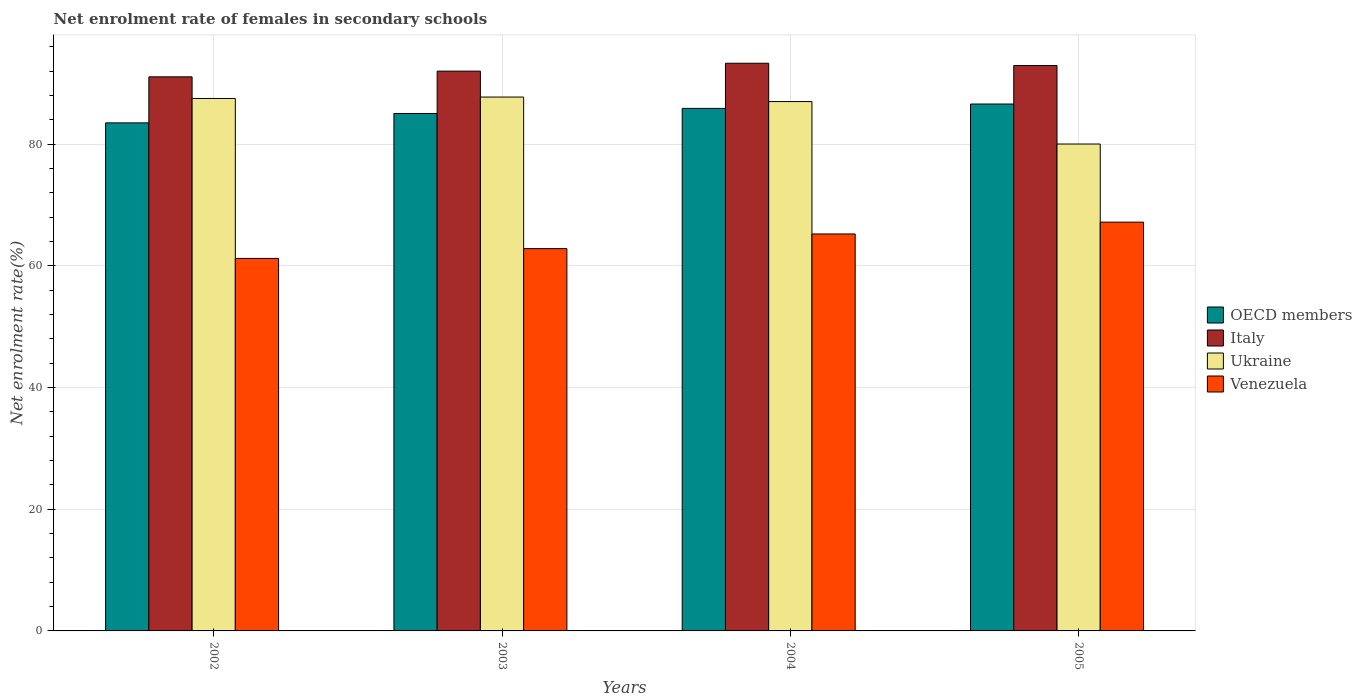How many different coloured bars are there?
Make the answer very short. 4. Are the number of bars on each tick of the X-axis equal?
Your answer should be compact. Yes. How many bars are there on the 4th tick from the left?
Make the answer very short. 4. What is the net enrolment rate of females in secondary schools in OECD members in 2002?
Offer a terse response. 83.5. Across all years, what is the maximum net enrolment rate of females in secondary schools in Ukraine?
Make the answer very short. 87.75. Across all years, what is the minimum net enrolment rate of females in secondary schools in Ukraine?
Make the answer very short. 80.02. In which year was the net enrolment rate of females in secondary schools in Venezuela minimum?
Your response must be concise. 2002. What is the total net enrolment rate of females in secondary schools in Italy in the graph?
Provide a short and direct response. 369.31. What is the difference between the net enrolment rate of females in secondary schools in Italy in 2002 and that in 2003?
Offer a very short reply. -0.94. What is the difference between the net enrolment rate of females in secondary schools in Ukraine in 2005 and the net enrolment rate of females in secondary schools in Italy in 2004?
Provide a succinct answer. -13.28. What is the average net enrolment rate of females in secondary schools in Ukraine per year?
Offer a very short reply. 85.57. In the year 2004, what is the difference between the net enrolment rate of females in secondary schools in Venezuela and net enrolment rate of females in secondary schools in OECD members?
Provide a short and direct response. -20.64. In how many years, is the net enrolment rate of females in secondary schools in OECD members greater than 8 %?
Your answer should be compact. 4. What is the ratio of the net enrolment rate of females in secondary schools in Venezuela in 2004 to that in 2005?
Your answer should be compact. 0.97. Is the difference between the net enrolment rate of females in secondary schools in Venezuela in 2002 and 2005 greater than the difference between the net enrolment rate of females in secondary schools in OECD members in 2002 and 2005?
Provide a succinct answer. No. What is the difference between the highest and the second highest net enrolment rate of females in secondary schools in Venezuela?
Provide a succinct answer. 1.94. What is the difference between the highest and the lowest net enrolment rate of females in secondary schools in Ukraine?
Keep it short and to the point. 7.72. In how many years, is the net enrolment rate of females in secondary schools in Venezuela greater than the average net enrolment rate of females in secondary schools in Venezuela taken over all years?
Your answer should be very brief. 2. What does the 2nd bar from the left in 2003 represents?
Your answer should be very brief. Italy. What does the 4th bar from the right in 2004 represents?
Your answer should be very brief. OECD members. How many bars are there?
Make the answer very short. 16. Are all the bars in the graph horizontal?
Provide a short and direct response. No. How many years are there in the graph?
Make the answer very short. 4. What is the difference between two consecutive major ticks on the Y-axis?
Your answer should be compact. 20. Are the values on the major ticks of Y-axis written in scientific E-notation?
Make the answer very short. No. Does the graph contain any zero values?
Make the answer very short. No. Where does the legend appear in the graph?
Your answer should be very brief. Center right. What is the title of the graph?
Make the answer very short. Net enrolment rate of females in secondary schools. What is the label or title of the Y-axis?
Your response must be concise. Net enrolment rate(%). What is the Net enrolment rate(%) in OECD members in 2002?
Give a very brief answer. 83.5. What is the Net enrolment rate(%) in Italy in 2002?
Provide a short and direct response. 91.07. What is the Net enrolment rate(%) in Ukraine in 2002?
Offer a very short reply. 87.51. What is the Net enrolment rate(%) of Venezuela in 2002?
Offer a very short reply. 61.22. What is the Net enrolment rate(%) in OECD members in 2003?
Ensure brevity in your answer.  85.05. What is the Net enrolment rate(%) of Italy in 2003?
Your response must be concise. 92.01. What is the Net enrolment rate(%) of Ukraine in 2003?
Your answer should be compact. 87.75. What is the Net enrolment rate(%) of Venezuela in 2003?
Ensure brevity in your answer.  62.83. What is the Net enrolment rate(%) in OECD members in 2004?
Provide a succinct answer. 85.88. What is the Net enrolment rate(%) in Italy in 2004?
Provide a short and direct response. 93.3. What is the Net enrolment rate(%) of Ukraine in 2004?
Keep it short and to the point. 87. What is the Net enrolment rate(%) of Venezuela in 2004?
Give a very brief answer. 65.24. What is the Net enrolment rate(%) of OECD members in 2005?
Make the answer very short. 86.6. What is the Net enrolment rate(%) in Italy in 2005?
Give a very brief answer. 92.93. What is the Net enrolment rate(%) of Ukraine in 2005?
Make the answer very short. 80.02. What is the Net enrolment rate(%) in Venezuela in 2005?
Offer a very short reply. 67.18. Across all years, what is the maximum Net enrolment rate(%) of OECD members?
Give a very brief answer. 86.6. Across all years, what is the maximum Net enrolment rate(%) in Italy?
Your response must be concise. 93.3. Across all years, what is the maximum Net enrolment rate(%) in Ukraine?
Offer a very short reply. 87.75. Across all years, what is the maximum Net enrolment rate(%) in Venezuela?
Provide a short and direct response. 67.18. Across all years, what is the minimum Net enrolment rate(%) in OECD members?
Give a very brief answer. 83.5. Across all years, what is the minimum Net enrolment rate(%) in Italy?
Provide a succinct answer. 91.07. Across all years, what is the minimum Net enrolment rate(%) in Ukraine?
Provide a succinct answer. 80.02. Across all years, what is the minimum Net enrolment rate(%) of Venezuela?
Ensure brevity in your answer.  61.22. What is the total Net enrolment rate(%) of OECD members in the graph?
Your answer should be compact. 341.03. What is the total Net enrolment rate(%) of Italy in the graph?
Your answer should be very brief. 369.31. What is the total Net enrolment rate(%) of Ukraine in the graph?
Offer a very short reply. 342.28. What is the total Net enrolment rate(%) in Venezuela in the graph?
Make the answer very short. 256.48. What is the difference between the Net enrolment rate(%) in OECD members in 2002 and that in 2003?
Your answer should be very brief. -1.54. What is the difference between the Net enrolment rate(%) of Italy in 2002 and that in 2003?
Provide a short and direct response. -0.94. What is the difference between the Net enrolment rate(%) of Ukraine in 2002 and that in 2003?
Give a very brief answer. -0.24. What is the difference between the Net enrolment rate(%) of Venezuela in 2002 and that in 2003?
Provide a succinct answer. -1.61. What is the difference between the Net enrolment rate(%) of OECD members in 2002 and that in 2004?
Give a very brief answer. -2.38. What is the difference between the Net enrolment rate(%) of Italy in 2002 and that in 2004?
Give a very brief answer. -2.23. What is the difference between the Net enrolment rate(%) of Ukraine in 2002 and that in 2004?
Ensure brevity in your answer.  0.51. What is the difference between the Net enrolment rate(%) in Venezuela in 2002 and that in 2004?
Your answer should be compact. -4.02. What is the difference between the Net enrolment rate(%) in OECD members in 2002 and that in 2005?
Your response must be concise. -3.1. What is the difference between the Net enrolment rate(%) of Italy in 2002 and that in 2005?
Make the answer very short. -1.87. What is the difference between the Net enrolment rate(%) in Ukraine in 2002 and that in 2005?
Offer a very short reply. 7.49. What is the difference between the Net enrolment rate(%) in Venezuela in 2002 and that in 2005?
Ensure brevity in your answer.  -5.96. What is the difference between the Net enrolment rate(%) in OECD members in 2003 and that in 2004?
Provide a short and direct response. -0.84. What is the difference between the Net enrolment rate(%) in Italy in 2003 and that in 2004?
Make the answer very short. -1.29. What is the difference between the Net enrolment rate(%) of Ukraine in 2003 and that in 2004?
Offer a very short reply. 0.74. What is the difference between the Net enrolment rate(%) of Venezuela in 2003 and that in 2004?
Your answer should be compact. -2.41. What is the difference between the Net enrolment rate(%) of OECD members in 2003 and that in 2005?
Make the answer very short. -1.55. What is the difference between the Net enrolment rate(%) in Italy in 2003 and that in 2005?
Your answer should be compact. -0.93. What is the difference between the Net enrolment rate(%) of Ukraine in 2003 and that in 2005?
Your response must be concise. 7.72. What is the difference between the Net enrolment rate(%) in Venezuela in 2003 and that in 2005?
Make the answer very short. -4.35. What is the difference between the Net enrolment rate(%) in OECD members in 2004 and that in 2005?
Give a very brief answer. -0.72. What is the difference between the Net enrolment rate(%) of Italy in 2004 and that in 2005?
Provide a succinct answer. 0.37. What is the difference between the Net enrolment rate(%) in Ukraine in 2004 and that in 2005?
Give a very brief answer. 6.98. What is the difference between the Net enrolment rate(%) in Venezuela in 2004 and that in 2005?
Provide a succinct answer. -1.94. What is the difference between the Net enrolment rate(%) of OECD members in 2002 and the Net enrolment rate(%) of Italy in 2003?
Your response must be concise. -8.5. What is the difference between the Net enrolment rate(%) of OECD members in 2002 and the Net enrolment rate(%) of Ukraine in 2003?
Your answer should be compact. -4.24. What is the difference between the Net enrolment rate(%) of OECD members in 2002 and the Net enrolment rate(%) of Venezuela in 2003?
Your response must be concise. 20.67. What is the difference between the Net enrolment rate(%) of Italy in 2002 and the Net enrolment rate(%) of Ukraine in 2003?
Offer a very short reply. 3.32. What is the difference between the Net enrolment rate(%) of Italy in 2002 and the Net enrolment rate(%) of Venezuela in 2003?
Keep it short and to the point. 28.23. What is the difference between the Net enrolment rate(%) in Ukraine in 2002 and the Net enrolment rate(%) in Venezuela in 2003?
Provide a short and direct response. 24.68. What is the difference between the Net enrolment rate(%) of OECD members in 2002 and the Net enrolment rate(%) of Italy in 2004?
Your answer should be compact. -9.8. What is the difference between the Net enrolment rate(%) of OECD members in 2002 and the Net enrolment rate(%) of Ukraine in 2004?
Offer a terse response. -3.5. What is the difference between the Net enrolment rate(%) in OECD members in 2002 and the Net enrolment rate(%) in Venezuela in 2004?
Offer a very short reply. 18.26. What is the difference between the Net enrolment rate(%) in Italy in 2002 and the Net enrolment rate(%) in Ukraine in 2004?
Your response must be concise. 4.07. What is the difference between the Net enrolment rate(%) in Italy in 2002 and the Net enrolment rate(%) in Venezuela in 2004?
Give a very brief answer. 25.82. What is the difference between the Net enrolment rate(%) in Ukraine in 2002 and the Net enrolment rate(%) in Venezuela in 2004?
Your answer should be compact. 22.27. What is the difference between the Net enrolment rate(%) in OECD members in 2002 and the Net enrolment rate(%) in Italy in 2005?
Your answer should be compact. -9.43. What is the difference between the Net enrolment rate(%) in OECD members in 2002 and the Net enrolment rate(%) in Ukraine in 2005?
Offer a terse response. 3.48. What is the difference between the Net enrolment rate(%) in OECD members in 2002 and the Net enrolment rate(%) in Venezuela in 2005?
Offer a very short reply. 16.32. What is the difference between the Net enrolment rate(%) in Italy in 2002 and the Net enrolment rate(%) in Ukraine in 2005?
Give a very brief answer. 11.04. What is the difference between the Net enrolment rate(%) in Italy in 2002 and the Net enrolment rate(%) in Venezuela in 2005?
Your answer should be very brief. 23.88. What is the difference between the Net enrolment rate(%) in Ukraine in 2002 and the Net enrolment rate(%) in Venezuela in 2005?
Your answer should be very brief. 20.33. What is the difference between the Net enrolment rate(%) of OECD members in 2003 and the Net enrolment rate(%) of Italy in 2004?
Make the answer very short. -8.25. What is the difference between the Net enrolment rate(%) of OECD members in 2003 and the Net enrolment rate(%) of Ukraine in 2004?
Your answer should be compact. -1.96. What is the difference between the Net enrolment rate(%) of OECD members in 2003 and the Net enrolment rate(%) of Venezuela in 2004?
Offer a terse response. 19.8. What is the difference between the Net enrolment rate(%) in Italy in 2003 and the Net enrolment rate(%) in Ukraine in 2004?
Your answer should be very brief. 5. What is the difference between the Net enrolment rate(%) of Italy in 2003 and the Net enrolment rate(%) of Venezuela in 2004?
Offer a terse response. 26.76. What is the difference between the Net enrolment rate(%) of Ukraine in 2003 and the Net enrolment rate(%) of Venezuela in 2004?
Your response must be concise. 22.5. What is the difference between the Net enrolment rate(%) in OECD members in 2003 and the Net enrolment rate(%) in Italy in 2005?
Provide a short and direct response. -7.89. What is the difference between the Net enrolment rate(%) in OECD members in 2003 and the Net enrolment rate(%) in Ukraine in 2005?
Your answer should be compact. 5.02. What is the difference between the Net enrolment rate(%) of OECD members in 2003 and the Net enrolment rate(%) of Venezuela in 2005?
Offer a terse response. 17.86. What is the difference between the Net enrolment rate(%) of Italy in 2003 and the Net enrolment rate(%) of Ukraine in 2005?
Keep it short and to the point. 11.98. What is the difference between the Net enrolment rate(%) of Italy in 2003 and the Net enrolment rate(%) of Venezuela in 2005?
Make the answer very short. 24.82. What is the difference between the Net enrolment rate(%) in Ukraine in 2003 and the Net enrolment rate(%) in Venezuela in 2005?
Make the answer very short. 20.56. What is the difference between the Net enrolment rate(%) in OECD members in 2004 and the Net enrolment rate(%) in Italy in 2005?
Your answer should be very brief. -7.05. What is the difference between the Net enrolment rate(%) in OECD members in 2004 and the Net enrolment rate(%) in Ukraine in 2005?
Keep it short and to the point. 5.86. What is the difference between the Net enrolment rate(%) of OECD members in 2004 and the Net enrolment rate(%) of Venezuela in 2005?
Offer a terse response. 18.7. What is the difference between the Net enrolment rate(%) in Italy in 2004 and the Net enrolment rate(%) in Ukraine in 2005?
Your answer should be very brief. 13.28. What is the difference between the Net enrolment rate(%) of Italy in 2004 and the Net enrolment rate(%) of Venezuela in 2005?
Keep it short and to the point. 26.12. What is the difference between the Net enrolment rate(%) in Ukraine in 2004 and the Net enrolment rate(%) in Venezuela in 2005?
Offer a very short reply. 19.82. What is the average Net enrolment rate(%) of OECD members per year?
Your response must be concise. 85.26. What is the average Net enrolment rate(%) of Italy per year?
Your answer should be very brief. 92.33. What is the average Net enrolment rate(%) in Ukraine per year?
Keep it short and to the point. 85.57. What is the average Net enrolment rate(%) of Venezuela per year?
Your response must be concise. 64.12. In the year 2002, what is the difference between the Net enrolment rate(%) of OECD members and Net enrolment rate(%) of Italy?
Your answer should be compact. -7.56. In the year 2002, what is the difference between the Net enrolment rate(%) in OECD members and Net enrolment rate(%) in Ukraine?
Your answer should be compact. -4.01. In the year 2002, what is the difference between the Net enrolment rate(%) in OECD members and Net enrolment rate(%) in Venezuela?
Your answer should be compact. 22.28. In the year 2002, what is the difference between the Net enrolment rate(%) in Italy and Net enrolment rate(%) in Ukraine?
Your answer should be very brief. 3.56. In the year 2002, what is the difference between the Net enrolment rate(%) in Italy and Net enrolment rate(%) in Venezuela?
Make the answer very short. 29.84. In the year 2002, what is the difference between the Net enrolment rate(%) of Ukraine and Net enrolment rate(%) of Venezuela?
Your response must be concise. 26.29. In the year 2003, what is the difference between the Net enrolment rate(%) of OECD members and Net enrolment rate(%) of Italy?
Give a very brief answer. -6.96. In the year 2003, what is the difference between the Net enrolment rate(%) of OECD members and Net enrolment rate(%) of Ukraine?
Your answer should be very brief. -2.7. In the year 2003, what is the difference between the Net enrolment rate(%) in OECD members and Net enrolment rate(%) in Venezuela?
Offer a terse response. 22.21. In the year 2003, what is the difference between the Net enrolment rate(%) in Italy and Net enrolment rate(%) in Ukraine?
Offer a very short reply. 4.26. In the year 2003, what is the difference between the Net enrolment rate(%) of Italy and Net enrolment rate(%) of Venezuela?
Your answer should be compact. 29.17. In the year 2003, what is the difference between the Net enrolment rate(%) in Ukraine and Net enrolment rate(%) in Venezuela?
Your answer should be very brief. 24.91. In the year 2004, what is the difference between the Net enrolment rate(%) in OECD members and Net enrolment rate(%) in Italy?
Offer a terse response. -7.42. In the year 2004, what is the difference between the Net enrolment rate(%) in OECD members and Net enrolment rate(%) in Ukraine?
Offer a terse response. -1.12. In the year 2004, what is the difference between the Net enrolment rate(%) in OECD members and Net enrolment rate(%) in Venezuela?
Provide a short and direct response. 20.64. In the year 2004, what is the difference between the Net enrolment rate(%) in Italy and Net enrolment rate(%) in Ukraine?
Offer a terse response. 6.3. In the year 2004, what is the difference between the Net enrolment rate(%) of Italy and Net enrolment rate(%) of Venezuela?
Ensure brevity in your answer.  28.06. In the year 2004, what is the difference between the Net enrolment rate(%) in Ukraine and Net enrolment rate(%) in Venezuela?
Ensure brevity in your answer.  21.76. In the year 2005, what is the difference between the Net enrolment rate(%) of OECD members and Net enrolment rate(%) of Italy?
Offer a very short reply. -6.33. In the year 2005, what is the difference between the Net enrolment rate(%) in OECD members and Net enrolment rate(%) in Ukraine?
Offer a very short reply. 6.57. In the year 2005, what is the difference between the Net enrolment rate(%) in OECD members and Net enrolment rate(%) in Venezuela?
Provide a succinct answer. 19.42. In the year 2005, what is the difference between the Net enrolment rate(%) in Italy and Net enrolment rate(%) in Ukraine?
Give a very brief answer. 12.91. In the year 2005, what is the difference between the Net enrolment rate(%) in Italy and Net enrolment rate(%) in Venezuela?
Keep it short and to the point. 25.75. In the year 2005, what is the difference between the Net enrolment rate(%) in Ukraine and Net enrolment rate(%) in Venezuela?
Make the answer very short. 12.84. What is the ratio of the Net enrolment rate(%) in OECD members in 2002 to that in 2003?
Provide a succinct answer. 0.98. What is the ratio of the Net enrolment rate(%) of Venezuela in 2002 to that in 2003?
Your answer should be very brief. 0.97. What is the ratio of the Net enrolment rate(%) of OECD members in 2002 to that in 2004?
Your answer should be compact. 0.97. What is the ratio of the Net enrolment rate(%) in Italy in 2002 to that in 2004?
Give a very brief answer. 0.98. What is the ratio of the Net enrolment rate(%) in Ukraine in 2002 to that in 2004?
Offer a very short reply. 1.01. What is the ratio of the Net enrolment rate(%) in Venezuela in 2002 to that in 2004?
Give a very brief answer. 0.94. What is the ratio of the Net enrolment rate(%) of OECD members in 2002 to that in 2005?
Keep it short and to the point. 0.96. What is the ratio of the Net enrolment rate(%) of Italy in 2002 to that in 2005?
Make the answer very short. 0.98. What is the ratio of the Net enrolment rate(%) in Ukraine in 2002 to that in 2005?
Provide a succinct answer. 1.09. What is the ratio of the Net enrolment rate(%) in Venezuela in 2002 to that in 2005?
Provide a succinct answer. 0.91. What is the ratio of the Net enrolment rate(%) in OECD members in 2003 to that in 2004?
Make the answer very short. 0.99. What is the ratio of the Net enrolment rate(%) in Italy in 2003 to that in 2004?
Your response must be concise. 0.99. What is the ratio of the Net enrolment rate(%) in Ukraine in 2003 to that in 2004?
Offer a terse response. 1.01. What is the ratio of the Net enrolment rate(%) of Venezuela in 2003 to that in 2004?
Offer a terse response. 0.96. What is the ratio of the Net enrolment rate(%) of OECD members in 2003 to that in 2005?
Make the answer very short. 0.98. What is the ratio of the Net enrolment rate(%) in Italy in 2003 to that in 2005?
Your answer should be very brief. 0.99. What is the ratio of the Net enrolment rate(%) of Ukraine in 2003 to that in 2005?
Ensure brevity in your answer.  1.1. What is the ratio of the Net enrolment rate(%) of Venezuela in 2003 to that in 2005?
Provide a short and direct response. 0.94. What is the ratio of the Net enrolment rate(%) of OECD members in 2004 to that in 2005?
Keep it short and to the point. 0.99. What is the ratio of the Net enrolment rate(%) of Italy in 2004 to that in 2005?
Offer a very short reply. 1. What is the ratio of the Net enrolment rate(%) of Ukraine in 2004 to that in 2005?
Offer a terse response. 1.09. What is the ratio of the Net enrolment rate(%) in Venezuela in 2004 to that in 2005?
Make the answer very short. 0.97. What is the difference between the highest and the second highest Net enrolment rate(%) in OECD members?
Ensure brevity in your answer.  0.72. What is the difference between the highest and the second highest Net enrolment rate(%) of Italy?
Your answer should be compact. 0.37. What is the difference between the highest and the second highest Net enrolment rate(%) in Ukraine?
Offer a terse response. 0.24. What is the difference between the highest and the second highest Net enrolment rate(%) of Venezuela?
Keep it short and to the point. 1.94. What is the difference between the highest and the lowest Net enrolment rate(%) in OECD members?
Your answer should be very brief. 3.1. What is the difference between the highest and the lowest Net enrolment rate(%) in Italy?
Your answer should be compact. 2.23. What is the difference between the highest and the lowest Net enrolment rate(%) of Ukraine?
Keep it short and to the point. 7.72. What is the difference between the highest and the lowest Net enrolment rate(%) of Venezuela?
Keep it short and to the point. 5.96. 